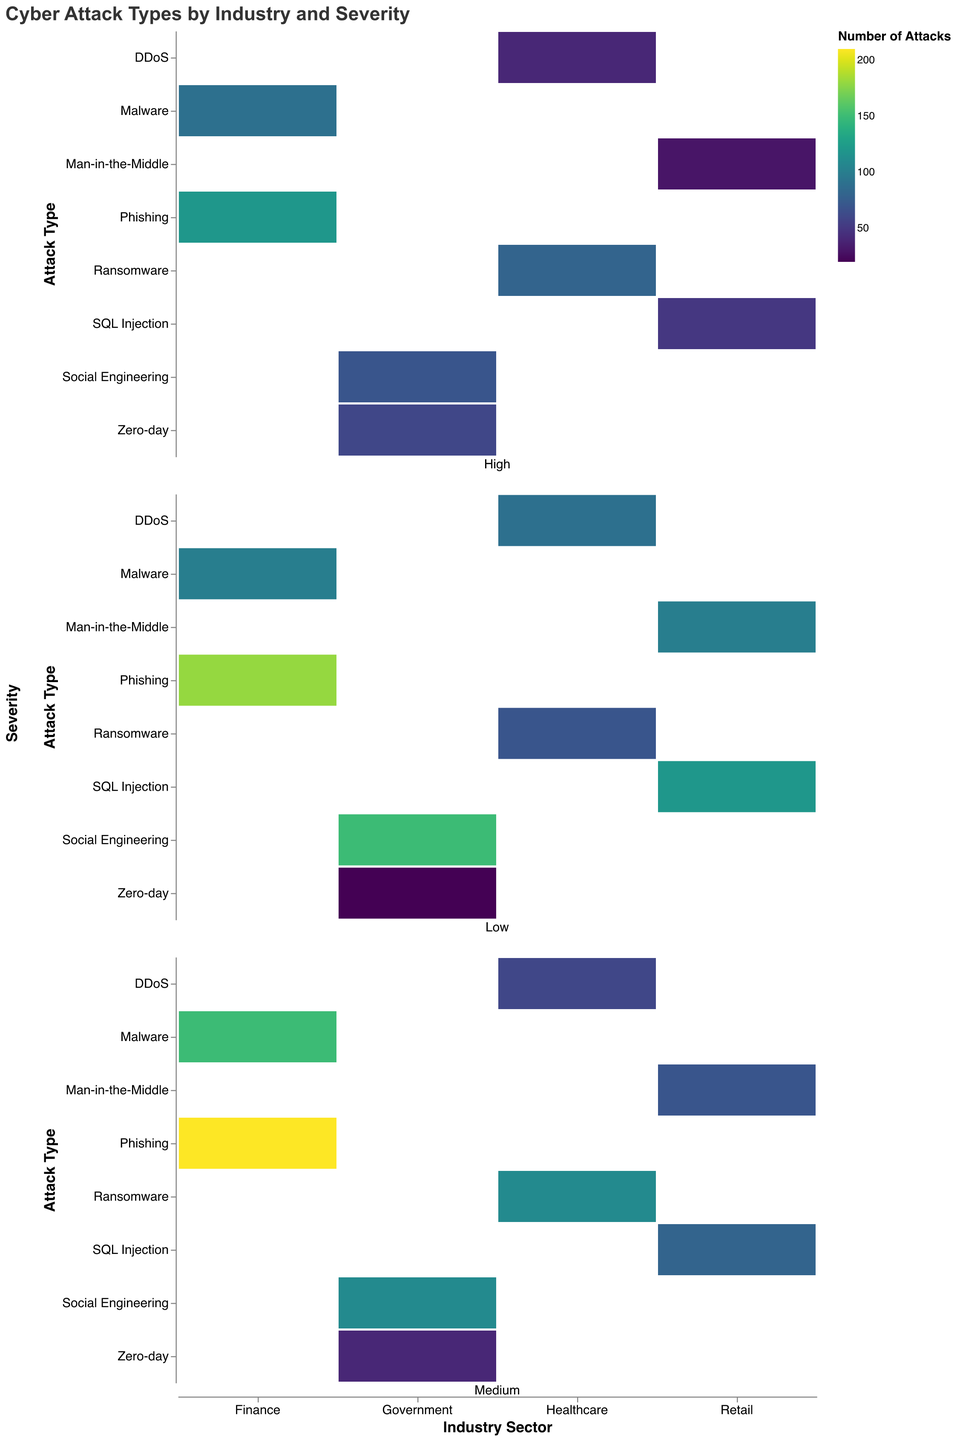What is the title of the figure? The title is usually displayed at the top of the figure in a larger font than the rest of the text. For this figure, it is "Cyber Attack Types by Industry and Severity."
Answer: Cyber Attack Types by Industry and Severity Which industry reported the highest number of high-severity attacks? Count the "High" severity attacks across all industries, finding the highest count. Finance has the highest number of high-severity attacks with a total of 210 attacks (120 Phishing + 90 Malware).
Answer: Finance How many low-severity Social Engineering attacks were reported in the Government industry? Locate the cell corresponding to Low severity and Social Engineering attack type in the Government industry. The count is 150.
Answer: 150 What is the most common attack type with medium severity in the Finance industry? Compare the medium severity attack counts within the Finance industry. Phishing has the highest number with 210 reports.
Answer: Phishing What is the total number of DDoS attacks reported in the Healthcare industry? Sum the counts for each severity level of DDoS attacks in the Healthcare industry: 40 (High) + 60 (Medium) + 90 (Low) = 190.
Answer: 190 Which industry has the least number of low-severity attacks? Compare the low-severity attack totals across all industries. Government has the least with only 20 (Zero-day) + 150 (Social Engineering) = 170.
Answer: Government How does the number of high-severity Ransomware attacks in Healthcare compare to the high-severity Phishing attacks in Finance? Look at the count of high-severity Ransomware in Healthcare (80) and compare it to high-severity Phishing in Finance (120). Finance has more high-severity Phishing attacks than Healthcare has Ransomware attacks.
Answer: Finance has more Which attack type in the Retail industry has more medium-severity occurrences: SQL Injection or Man-in-the-Middle? Compare the medium-severity attack counts for SQL Injection (80) and Man-in-the-Middle (70) within the Retail industry. SQL Injection has more medium-severity occurrences.
Answer: SQL Injection What is the total number of medium-severity attacks reported in the Government industry? Sum the medium-severity attack counts for each type in the Government industry: 40 (Zero-day) + 110 (Social Engineering) = 150.
Answer: 150 